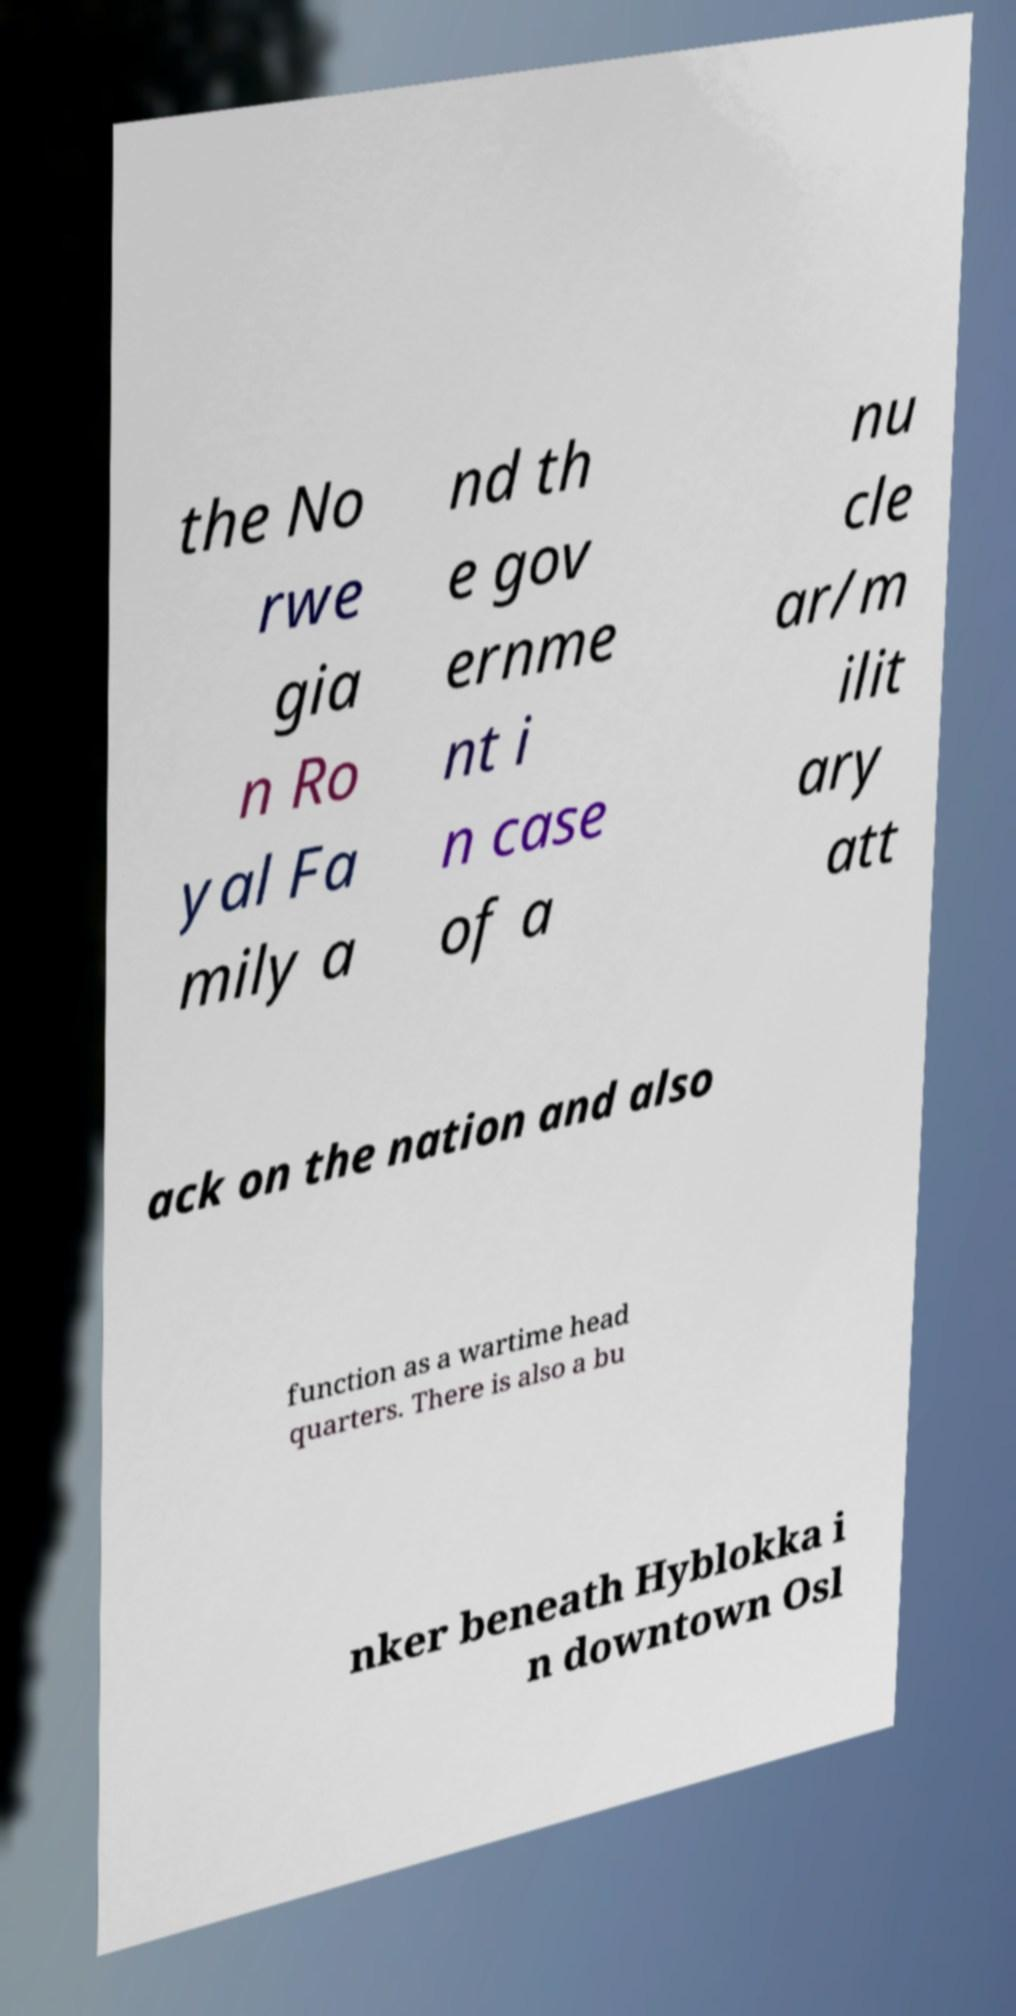There's text embedded in this image that I need extracted. Can you transcribe it verbatim? the No rwe gia n Ro yal Fa mily a nd th e gov ernme nt i n case of a nu cle ar/m ilit ary att ack on the nation and also function as a wartime head quarters. There is also a bu nker beneath Hyblokka i n downtown Osl 